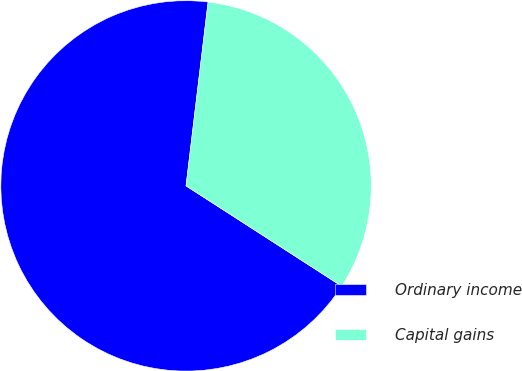<chart> <loc_0><loc_0><loc_500><loc_500><pie_chart><fcel>Ordinary income<fcel>Capital gains<nl><fcel>67.79%<fcel>32.21%<nl></chart> 